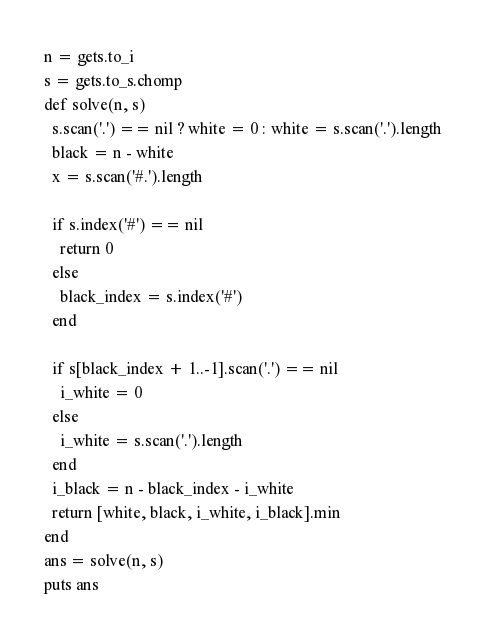Convert code to text. <code><loc_0><loc_0><loc_500><loc_500><_Ruby_>n = gets.to_i
s = gets.to_s.chomp
def solve(n, s)
  s.scan('.') == nil ? white = 0 : white = s.scan('.').length
  black = n - white
  x = s.scan('#.').length

  if s.index('#') == nil
    return 0
  else
    black_index = s.index('#')
  end

  if s[black_index + 1..-1].scan('.') == nil
    i_white = 0
  else
    i_white = s.scan('.').length
  end
  i_black = n - black_index - i_white
  return [white, black, i_white, i_black].min
end
ans = solve(n, s)
puts ans
</code> 